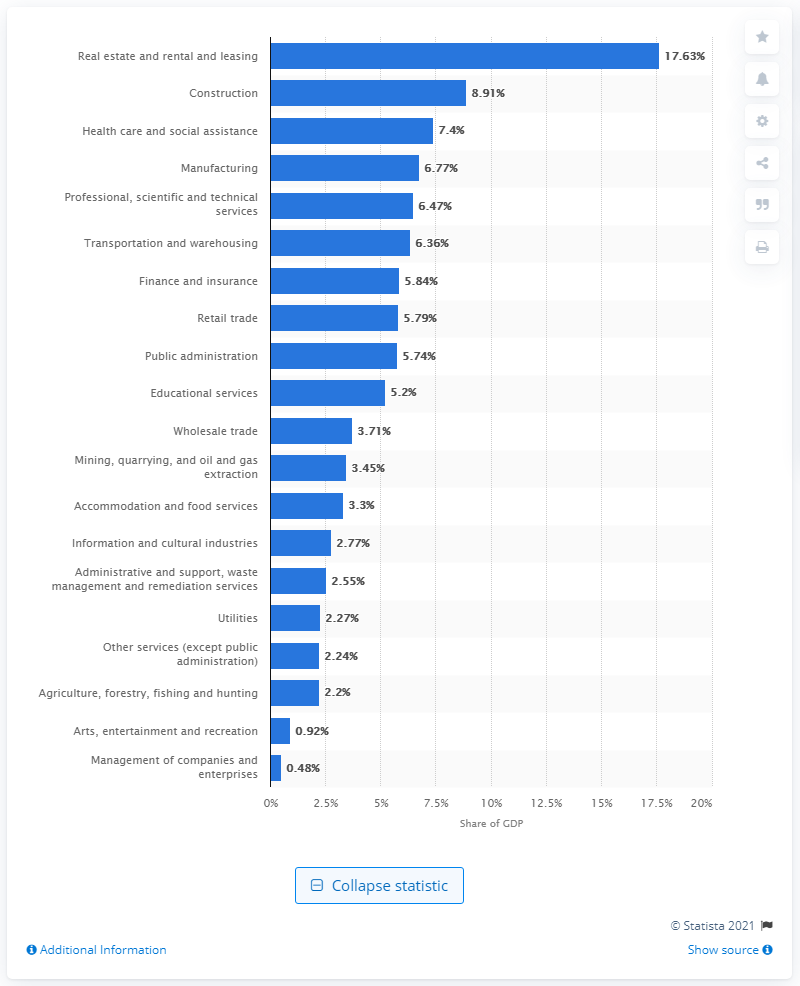List a handful of essential elements in this visual. In 2019, the construction industry accounted for approximately 8.91% of British Columbia's Gross Domestic Product (GDP). 